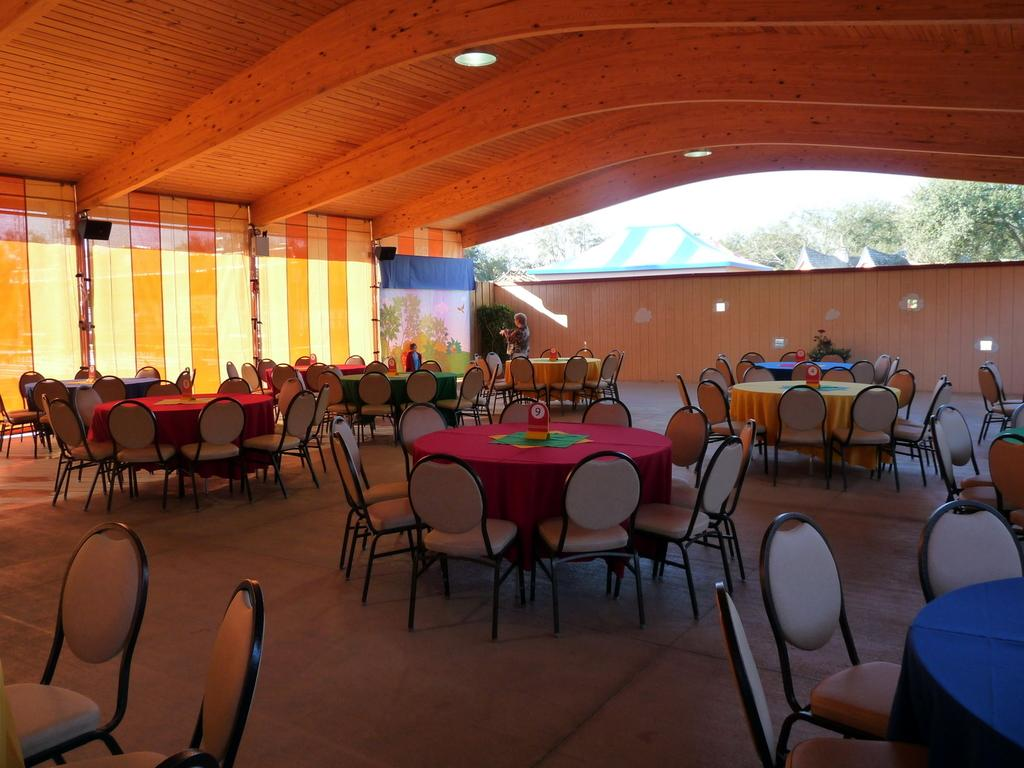What type of furniture is present in the hall in the image? There are dining tables in the hall in the image. Can you describe the people in the image? There are two people standing at the back in the image. What is the unique feature of the wall in the image? There is a cloth wall in the image. What structure can be seen on the top in the image? There is a shed on the top in the image. What year is depicted in the image? The image does not depict a specific year; it is a still image of a scene. Can you tell me how many knives are on the dining tables in the image? There is no mention of knives in the provided facts, so we cannot determine their presence or quantity in the image. 